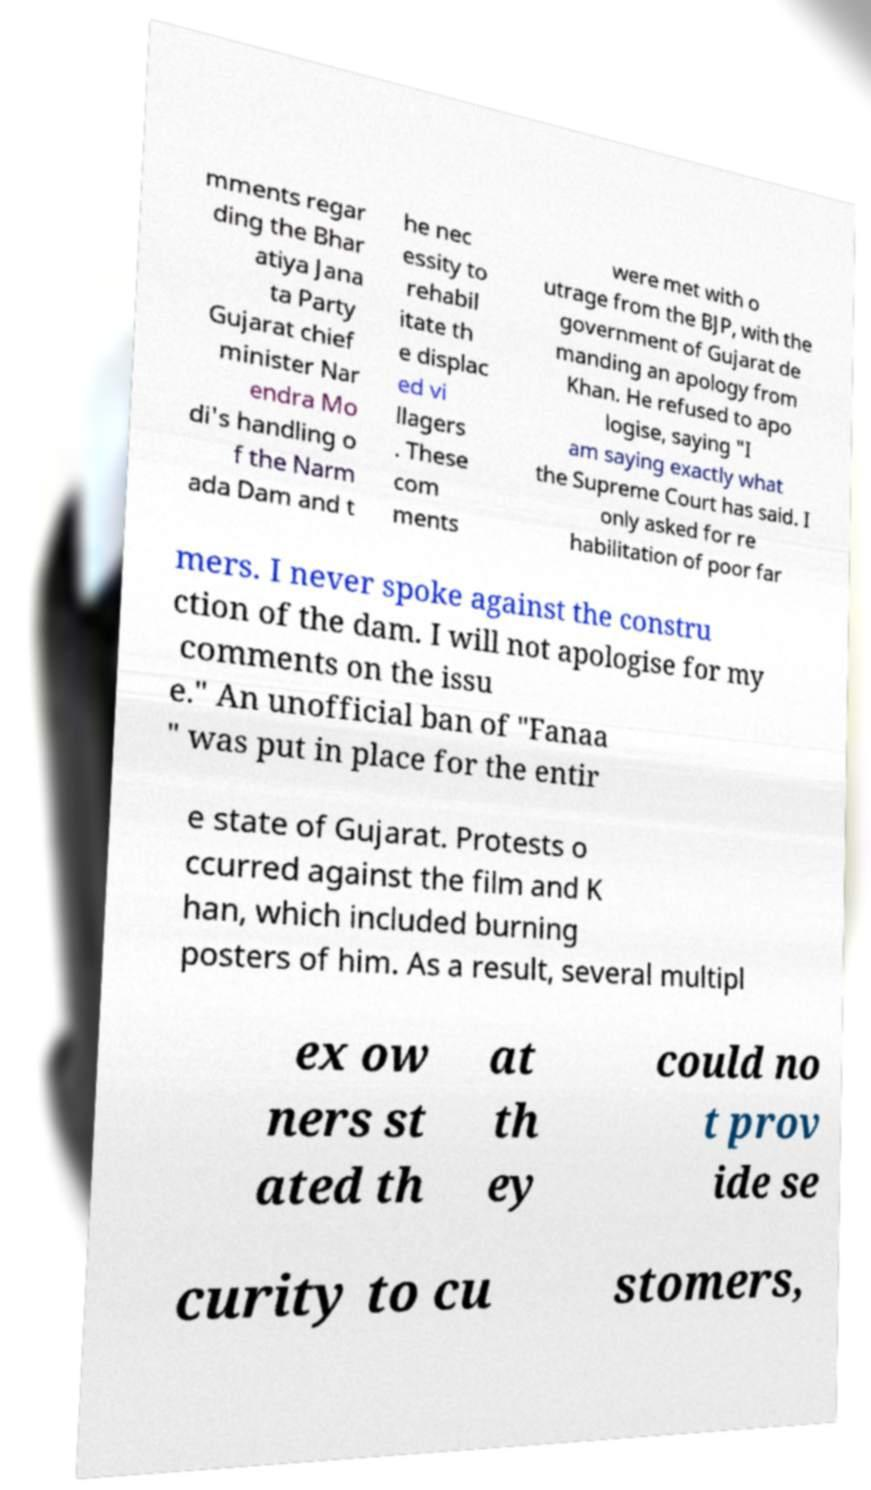Please identify and transcribe the text found in this image. mments regar ding the Bhar atiya Jana ta Party Gujarat chief minister Nar endra Mo di's handling o f the Narm ada Dam and t he nec essity to rehabil itate th e displac ed vi llagers . These com ments were met with o utrage from the BJP, with the government of Gujarat de manding an apology from Khan. He refused to apo logise, saying "I am saying exactly what the Supreme Court has said. I only asked for re habilitation of poor far mers. I never spoke against the constru ction of the dam. I will not apologise for my comments on the issu e." An unofficial ban of "Fanaa " was put in place for the entir e state of Gujarat. Protests o ccurred against the film and K han, which included burning posters of him. As a result, several multipl ex ow ners st ated th at th ey could no t prov ide se curity to cu stomers, 